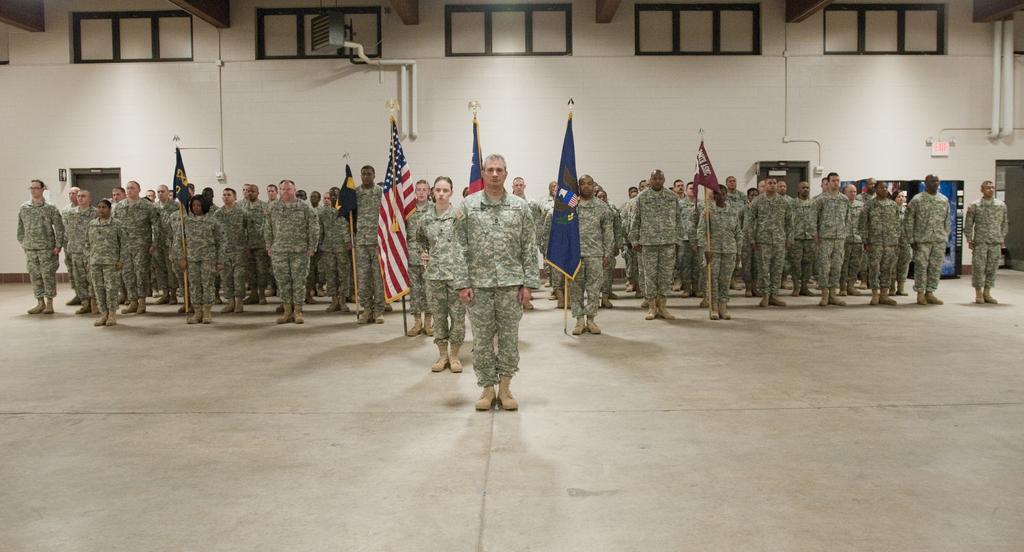Please provide a concise description of this image. In this image we can see the people wearing the military uniform and standing on the surface. We can also see the flags, wall, pipes, doors and also the windows. 